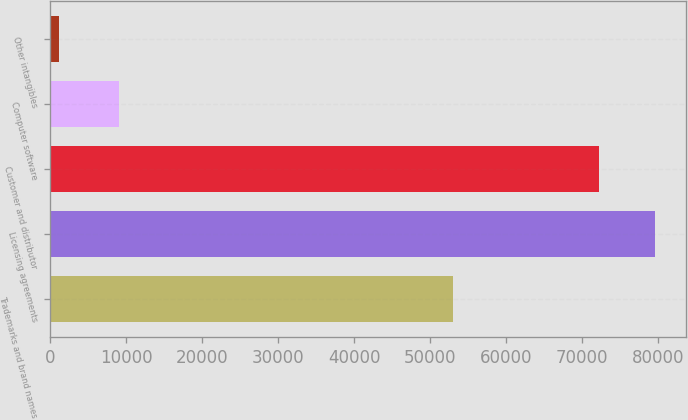<chart> <loc_0><loc_0><loc_500><loc_500><bar_chart><fcel>Trademarks and brand names<fcel>Licensing agreements<fcel>Customer and distributor<fcel>Computer software<fcel>Other intangibles<nl><fcel>53001<fcel>79610.7<fcel>72180<fcel>9001<fcel>1177<nl></chart> 